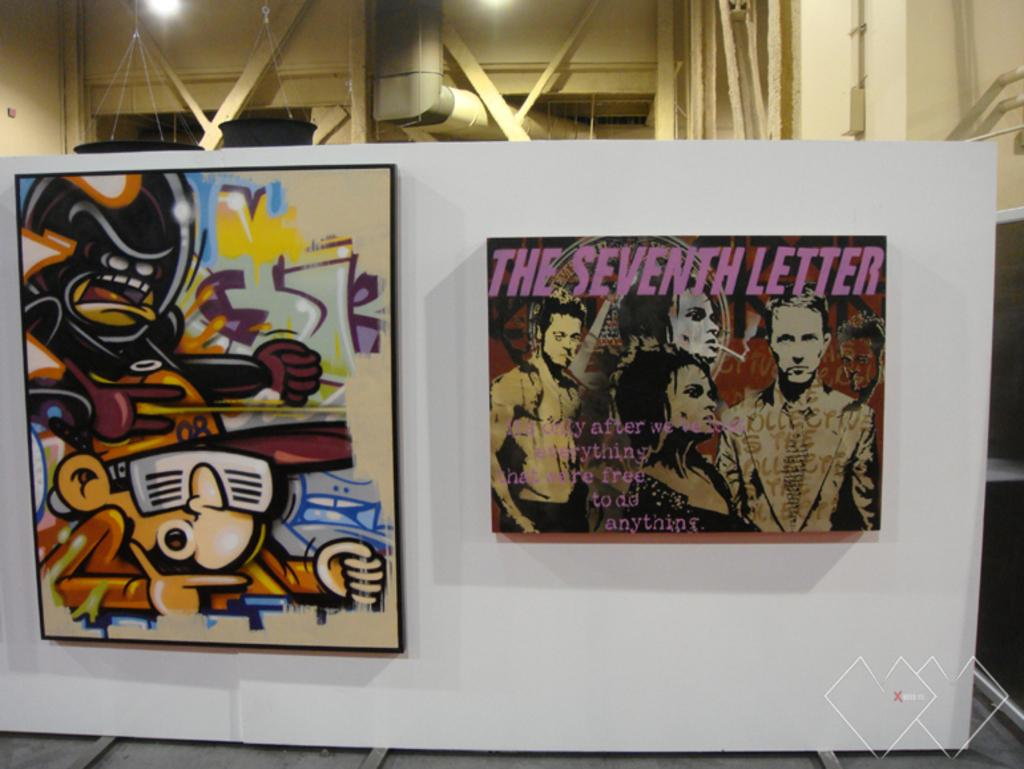Provide a one-sentence caption for the provided image. A poster featuring cartoon characters is setting to the left of the poster for labeled: "The Seventh Letter". 